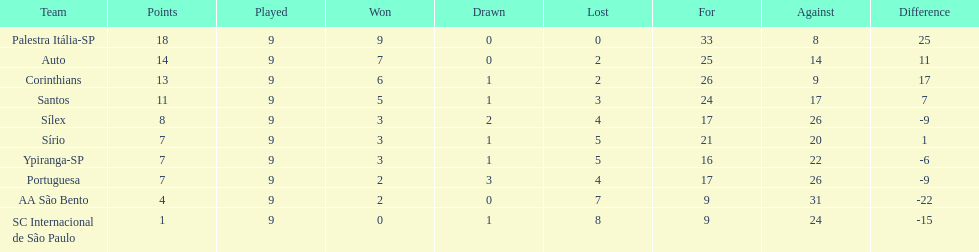In 1926 brazilian soccer, excluding the premier team, which other teams had triumphing records? Auto, Corinthians, Santos. 